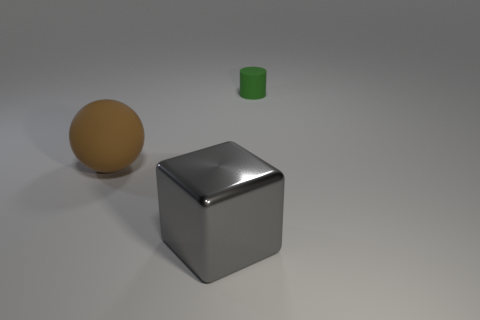Add 1 tiny rubber objects. How many objects exist? 4 Subtract all cylinders. How many objects are left? 2 Add 2 green rubber things. How many green rubber things are left? 3 Add 3 large matte cubes. How many large matte cubes exist? 3 Subtract 0 blue spheres. How many objects are left? 3 Subtract all big gray shiny objects. Subtract all matte balls. How many objects are left? 1 